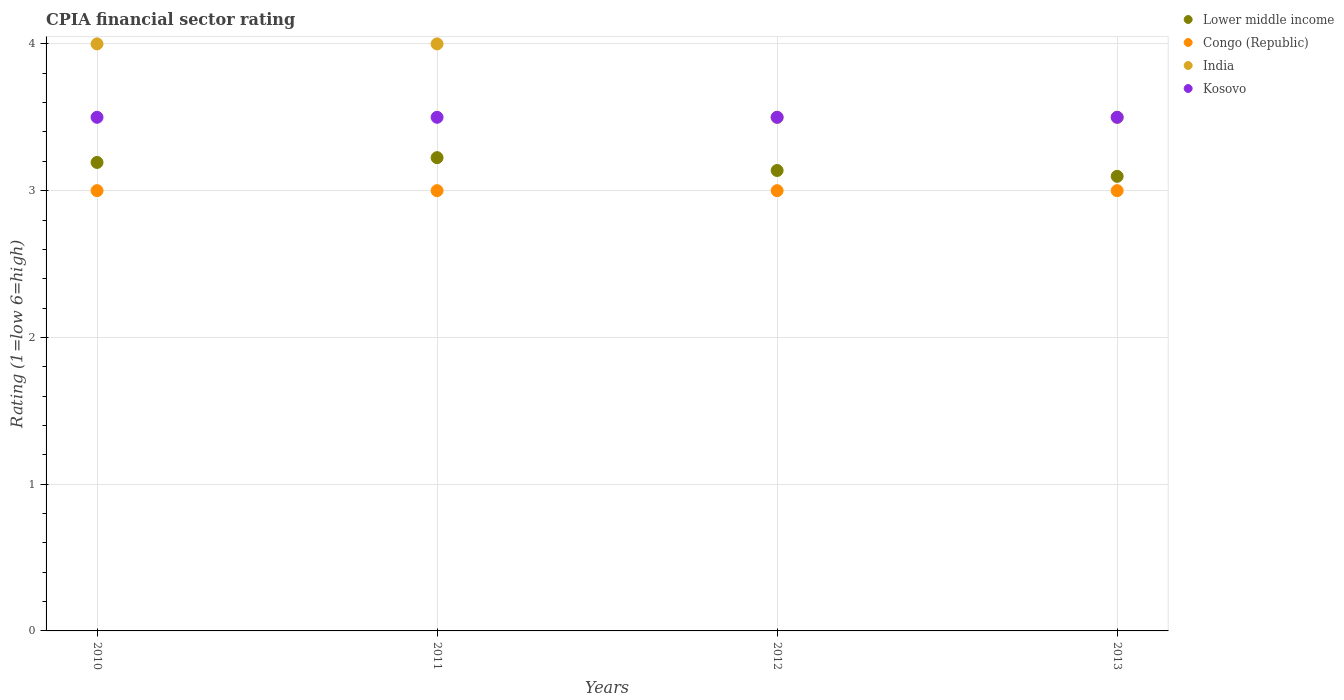How many different coloured dotlines are there?
Your answer should be very brief. 4. Across all years, what is the maximum CPIA rating in India?
Ensure brevity in your answer.  4. In which year was the CPIA rating in Lower middle income maximum?
Provide a succinct answer. 2011. What is the difference between the CPIA rating in Lower middle income in 2011 and that in 2013?
Offer a very short reply. 0.13. What is the difference between the CPIA rating in India in 2010 and the CPIA rating in Kosovo in 2012?
Offer a very short reply. 0.5. What is the average CPIA rating in Kosovo per year?
Offer a very short reply. 3.5. In the year 2011, what is the difference between the CPIA rating in India and CPIA rating in Lower middle income?
Your answer should be very brief. 0.77. What is the ratio of the CPIA rating in Congo (Republic) in 2012 to that in 2013?
Provide a succinct answer. 1. Is the difference between the CPIA rating in India in 2012 and 2013 greater than the difference between the CPIA rating in Lower middle income in 2012 and 2013?
Your answer should be compact. No. What is the difference between the highest and the lowest CPIA rating in India?
Provide a short and direct response. 0.5. In how many years, is the CPIA rating in Kosovo greater than the average CPIA rating in Kosovo taken over all years?
Your answer should be very brief. 0. Is it the case that in every year, the sum of the CPIA rating in Congo (Republic) and CPIA rating in India  is greater than the CPIA rating in Kosovo?
Offer a very short reply. Yes. How many years are there in the graph?
Your answer should be compact. 4. Are the values on the major ticks of Y-axis written in scientific E-notation?
Your response must be concise. No. Does the graph contain grids?
Ensure brevity in your answer.  Yes. Where does the legend appear in the graph?
Provide a succinct answer. Top right. What is the title of the graph?
Provide a succinct answer. CPIA financial sector rating. Does "Gambia, The" appear as one of the legend labels in the graph?
Offer a very short reply. No. What is the label or title of the X-axis?
Offer a terse response. Years. What is the Rating (1=low 6=high) in Lower middle income in 2010?
Provide a succinct answer. 3.19. What is the Rating (1=low 6=high) in Congo (Republic) in 2010?
Provide a short and direct response. 3. What is the Rating (1=low 6=high) of India in 2010?
Keep it short and to the point. 4. What is the Rating (1=low 6=high) in Lower middle income in 2011?
Give a very brief answer. 3.23. What is the Rating (1=low 6=high) in Congo (Republic) in 2011?
Offer a very short reply. 3. What is the Rating (1=low 6=high) in India in 2011?
Your response must be concise. 4. What is the Rating (1=low 6=high) of Kosovo in 2011?
Offer a very short reply. 3.5. What is the Rating (1=low 6=high) of Lower middle income in 2012?
Offer a very short reply. 3.14. What is the Rating (1=low 6=high) in Congo (Republic) in 2012?
Offer a terse response. 3. What is the Rating (1=low 6=high) of Lower middle income in 2013?
Offer a very short reply. 3.1. What is the Rating (1=low 6=high) of Congo (Republic) in 2013?
Make the answer very short. 3. What is the Rating (1=low 6=high) of Kosovo in 2013?
Make the answer very short. 3.5. Across all years, what is the maximum Rating (1=low 6=high) of Lower middle income?
Your answer should be compact. 3.23. Across all years, what is the maximum Rating (1=low 6=high) in Congo (Republic)?
Your response must be concise. 3. Across all years, what is the maximum Rating (1=low 6=high) in India?
Provide a short and direct response. 4. Across all years, what is the maximum Rating (1=low 6=high) of Kosovo?
Offer a very short reply. 3.5. Across all years, what is the minimum Rating (1=low 6=high) in Lower middle income?
Keep it short and to the point. 3.1. Across all years, what is the minimum Rating (1=low 6=high) in Congo (Republic)?
Your answer should be compact. 3. Across all years, what is the minimum Rating (1=low 6=high) in India?
Make the answer very short. 3.5. Across all years, what is the minimum Rating (1=low 6=high) of Kosovo?
Offer a terse response. 3.5. What is the total Rating (1=low 6=high) in Lower middle income in the graph?
Provide a short and direct response. 12.65. What is the total Rating (1=low 6=high) of Congo (Republic) in the graph?
Ensure brevity in your answer.  12. What is the difference between the Rating (1=low 6=high) in Lower middle income in 2010 and that in 2011?
Your answer should be compact. -0.03. What is the difference between the Rating (1=low 6=high) of Lower middle income in 2010 and that in 2012?
Offer a very short reply. 0.05. What is the difference between the Rating (1=low 6=high) of India in 2010 and that in 2012?
Give a very brief answer. 0.5. What is the difference between the Rating (1=low 6=high) of Lower middle income in 2010 and that in 2013?
Give a very brief answer. 0.09. What is the difference between the Rating (1=low 6=high) of Lower middle income in 2011 and that in 2012?
Provide a short and direct response. 0.09. What is the difference between the Rating (1=low 6=high) in India in 2011 and that in 2012?
Give a very brief answer. 0.5. What is the difference between the Rating (1=low 6=high) in Lower middle income in 2011 and that in 2013?
Offer a very short reply. 0.13. What is the difference between the Rating (1=low 6=high) of Lower middle income in 2012 and that in 2013?
Make the answer very short. 0.04. What is the difference between the Rating (1=low 6=high) of Lower middle income in 2010 and the Rating (1=low 6=high) of Congo (Republic) in 2011?
Your response must be concise. 0.19. What is the difference between the Rating (1=low 6=high) in Lower middle income in 2010 and the Rating (1=low 6=high) in India in 2011?
Offer a terse response. -0.81. What is the difference between the Rating (1=low 6=high) of Lower middle income in 2010 and the Rating (1=low 6=high) of Kosovo in 2011?
Give a very brief answer. -0.31. What is the difference between the Rating (1=low 6=high) of Congo (Republic) in 2010 and the Rating (1=low 6=high) of India in 2011?
Your response must be concise. -1. What is the difference between the Rating (1=low 6=high) in Congo (Republic) in 2010 and the Rating (1=low 6=high) in Kosovo in 2011?
Make the answer very short. -0.5. What is the difference between the Rating (1=low 6=high) in Lower middle income in 2010 and the Rating (1=low 6=high) in Congo (Republic) in 2012?
Offer a terse response. 0.19. What is the difference between the Rating (1=low 6=high) in Lower middle income in 2010 and the Rating (1=low 6=high) in India in 2012?
Make the answer very short. -0.31. What is the difference between the Rating (1=low 6=high) in Lower middle income in 2010 and the Rating (1=low 6=high) in Kosovo in 2012?
Offer a terse response. -0.31. What is the difference between the Rating (1=low 6=high) in Congo (Republic) in 2010 and the Rating (1=low 6=high) in India in 2012?
Keep it short and to the point. -0.5. What is the difference between the Rating (1=low 6=high) in Congo (Republic) in 2010 and the Rating (1=low 6=high) in Kosovo in 2012?
Provide a short and direct response. -0.5. What is the difference between the Rating (1=low 6=high) in Lower middle income in 2010 and the Rating (1=low 6=high) in Congo (Republic) in 2013?
Your answer should be very brief. 0.19. What is the difference between the Rating (1=low 6=high) of Lower middle income in 2010 and the Rating (1=low 6=high) of India in 2013?
Your answer should be compact. -0.31. What is the difference between the Rating (1=low 6=high) in Lower middle income in 2010 and the Rating (1=low 6=high) in Kosovo in 2013?
Ensure brevity in your answer.  -0.31. What is the difference between the Rating (1=low 6=high) in Congo (Republic) in 2010 and the Rating (1=low 6=high) in India in 2013?
Your answer should be compact. -0.5. What is the difference between the Rating (1=low 6=high) in India in 2010 and the Rating (1=low 6=high) in Kosovo in 2013?
Ensure brevity in your answer.  0.5. What is the difference between the Rating (1=low 6=high) in Lower middle income in 2011 and the Rating (1=low 6=high) in Congo (Republic) in 2012?
Provide a short and direct response. 0.23. What is the difference between the Rating (1=low 6=high) of Lower middle income in 2011 and the Rating (1=low 6=high) of India in 2012?
Your response must be concise. -0.28. What is the difference between the Rating (1=low 6=high) in Lower middle income in 2011 and the Rating (1=low 6=high) in Kosovo in 2012?
Your answer should be compact. -0.28. What is the difference between the Rating (1=low 6=high) of Congo (Republic) in 2011 and the Rating (1=low 6=high) of India in 2012?
Your response must be concise. -0.5. What is the difference between the Rating (1=low 6=high) of Congo (Republic) in 2011 and the Rating (1=low 6=high) of Kosovo in 2012?
Your answer should be compact. -0.5. What is the difference between the Rating (1=low 6=high) of Lower middle income in 2011 and the Rating (1=low 6=high) of Congo (Republic) in 2013?
Offer a terse response. 0.23. What is the difference between the Rating (1=low 6=high) of Lower middle income in 2011 and the Rating (1=low 6=high) of India in 2013?
Keep it short and to the point. -0.28. What is the difference between the Rating (1=low 6=high) of Lower middle income in 2011 and the Rating (1=low 6=high) of Kosovo in 2013?
Make the answer very short. -0.28. What is the difference between the Rating (1=low 6=high) of Congo (Republic) in 2011 and the Rating (1=low 6=high) of India in 2013?
Provide a short and direct response. -0.5. What is the difference between the Rating (1=low 6=high) in Congo (Republic) in 2011 and the Rating (1=low 6=high) in Kosovo in 2013?
Keep it short and to the point. -0.5. What is the difference between the Rating (1=low 6=high) of India in 2011 and the Rating (1=low 6=high) of Kosovo in 2013?
Your answer should be compact. 0.5. What is the difference between the Rating (1=low 6=high) of Lower middle income in 2012 and the Rating (1=low 6=high) of Congo (Republic) in 2013?
Your answer should be very brief. 0.14. What is the difference between the Rating (1=low 6=high) in Lower middle income in 2012 and the Rating (1=low 6=high) in India in 2013?
Offer a very short reply. -0.36. What is the difference between the Rating (1=low 6=high) in Lower middle income in 2012 and the Rating (1=low 6=high) in Kosovo in 2013?
Ensure brevity in your answer.  -0.36. What is the difference between the Rating (1=low 6=high) in Congo (Republic) in 2012 and the Rating (1=low 6=high) in Kosovo in 2013?
Ensure brevity in your answer.  -0.5. What is the difference between the Rating (1=low 6=high) in India in 2012 and the Rating (1=low 6=high) in Kosovo in 2013?
Your answer should be compact. 0. What is the average Rating (1=low 6=high) in Lower middle income per year?
Your answer should be very brief. 3.16. What is the average Rating (1=low 6=high) of Congo (Republic) per year?
Your answer should be very brief. 3. What is the average Rating (1=low 6=high) in India per year?
Provide a succinct answer. 3.75. In the year 2010, what is the difference between the Rating (1=low 6=high) of Lower middle income and Rating (1=low 6=high) of Congo (Republic)?
Your answer should be very brief. 0.19. In the year 2010, what is the difference between the Rating (1=low 6=high) in Lower middle income and Rating (1=low 6=high) in India?
Give a very brief answer. -0.81. In the year 2010, what is the difference between the Rating (1=low 6=high) in Lower middle income and Rating (1=low 6=high) in Kosovo?
Offer a terse response. -0.31. In the year 2010, what is the difference between the Rating (1=low 6=high) in Congo (Republic) and Rating (1=low 6=high) in Kosovo?
Provide a succinct answer. -0.5. In the year 2010, what is the difference between the Rating (1=low 6=high) of India and Rating (1=low 6=high) of Kosovo?
Make the answer very short. 0.5. In the year 2011, what is the difference between the Rating (1=low 6=high) in Lower middle income and Rating (1=low 6=high) in Congo (Republic)?
Offer a terse response. 0.23. In the year 2011, what is the difference between the Rating (1=low 6=high) of Lower middle income and Rating (1=low 6=high) of India?
Give a very brief answer. -0.78. In the year 2011, what is the difference between the Rating (1=low 6=high) of Lower middle income and Rating (1=low 6=high) of Kosovo?
Keep it short and to the point. -0.28. In the year 2011, what is the difference between the Rating (1=low 6=high) in India and Rating (1=low 6=high) in Kosovo?
Your answer should be very brief. 0.5. In the year 2012, what is the difference between the Rating (1=low 6=high) of Lower middle income and Rating (1=low 6=high) of Congo (Republic)?
Give a very brief answer. 0.14. In the year 2012, what is the difference between the Rating (1=low 6=high) of Lower middle income and Rating (1=low 6=high) of India?
Ensure brevity in your answer.  -0.36. In the year 2012, what is the difference between the Rating (1=low 6=high) of Lower middle income and Rating (1=low 6=high) of Kosovo?
Ensure brevity in your answer.  -0.36. In the year 2012, what is the difference between the Rating (1=low 6=high) in Congo (Republic) and Rating (1=low 6=high) in India?
Provide a succinct answer. -0.5. In the year 2012, what is the difference between the Rating (1=low 6=high) in India and Rating (1=low 6=high) in Kosovo?
Your answer should be compact. 0. In the year 2013, what is the difference between the Rating (1=low 6=high) of Lower middle income and Rating (1=low 6=high) of Congo (Republic)?
Keep it short and to the point. 0.1. In the year 2013, what is the difference between the Rating (1=low 6=high) in Lower middle income and Rating (1=low 6=high) in India?
Keep it short and to the point. -0.4. In the year 2013, what is the difference between the Rating (1=low 6=high) of Lower middle income and Rating (1=low 6=high) of Kosovo?
Keep it short and to the point. -0.4. In the year 2013, what is the difference between the Rating (1=low 6=high) of Congo (Republic) and Rating (1=low 6=high) of India?
Keep it short and to the point. -0.5. In the year 2013, what is the difference between the Rating (1=low 6=high) of Congo (Republic) and Rating (1=low 6=high) of Kosovo?
Give a very brief answer. -0.5. In the year 2013, what is the difference between the Rating (1=low 6=high) in India and Rating (1=low 6=high) in Kosovo?
Provide a succinct answer. 0. What is the ratio of the Rating (1=low 6=high) in Lower middle income in 2010 to that in 2011?
Ensure brevity in your answer.  0.99. What is the ratio of the Rating (1=low 6=high) of India in 2010 to that in 2011?
Your answer should be compact. 1. What is the ratio of the Rating (1=low 6=high) in Lower middle income in 2010 to that in 2012?
Keep it short and to the point. 1.02. What is the ratio of the Rating (1=low 6=high) of India in 2010 to that in 2012?
Keep it short and to the point. 1.14. What is the ratio of the Rating (1=low 6=high) of Lower middle income in 2010 to that in 2013?
Provide a short and direct response. 1.03. What is the ratio of the Rating (1=low 6=high) in Congo (Republic) in 2010 to that in 2013?
Offer a very short reply. 1. What is the ratio of the Rating (1=low 6=high) in India in 2010 to that in 2013?
Give a very brief answer. 1.14. What is the ratio of the Rating (1=low 6=high) of Lower middle income in 2011 to that in 2012?
Ensure brevity in your answer.  1.03. What is the ratio of the Rating (1=low 6=high) of Congo (Republic) in 2011 to that in 2012?
Make the answer very short. 1. What is the ratio of the Rating (1=low 6=high) in Kosovo in 2011 to that in 2012?
Provide a succinct answer. 1. What is the ratio of the Rating (1=low 6=high) in Lower middle income in 2011 to that in 2013?
Make the answer very short. 1.04. What is the ratio of the Rating (1=low 6=high) in Kosovo in 2011 to that in 2013?
Your response must be concise. 1. What is the ratio of the Rating (1=low 6=high) of Lower middle income in 2012 to that in 2013?
Offer a terse response. 1.01. What is the ratio of the Rating (1=low 6=high) in India in 2012 to that in 2013?
Make the answer very short. 1. What is the ratio of the Rating (1=low 6=high) in Kosovo in 2012 to that in 2013?
Offer a terse response. 1. What is the difference between the highest and the second highest Rating (1=low 6=high) of Lower middle income?
Your answer should be compact. 0.03. What is the difference between the highest and the lowest Rating (1=low 6=high) in Lower middle income?
Provide a short and direct response. 0.13. What is the difference between the highest and the lowest Rating (1=low 6=high) of India?
Your response must be concise. 0.5. What is the difference between the highest and the lowest Rating (1=low 6=high) of Kosovo?
Make the answer very short. 0. 